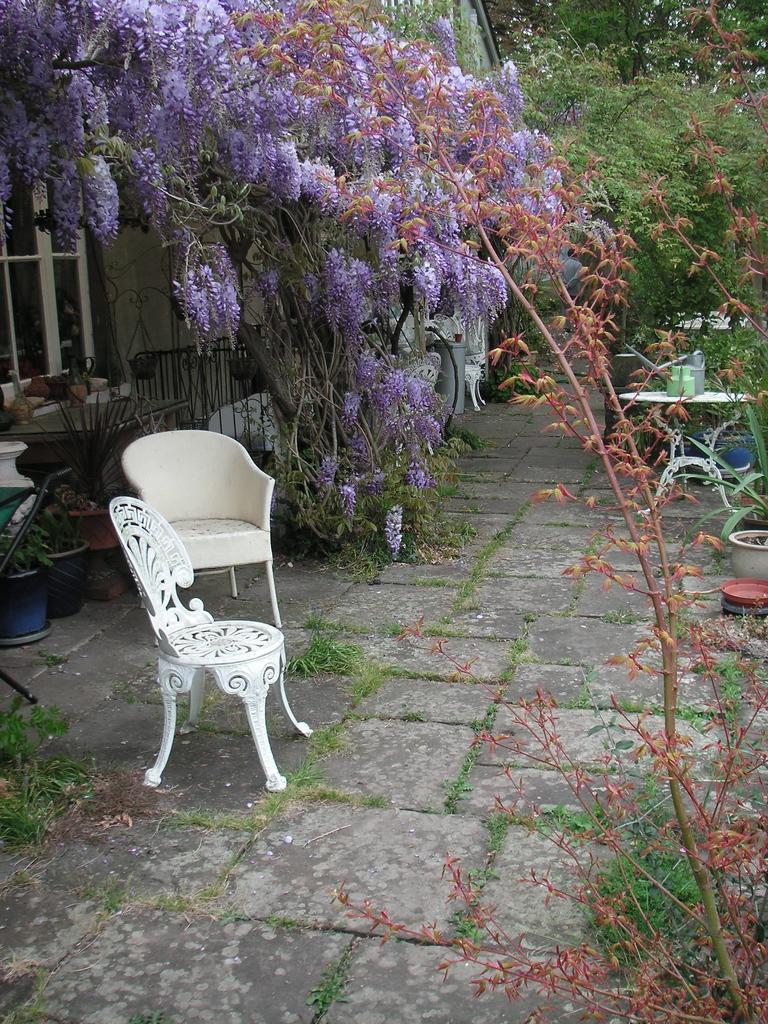Describe this image in one or two sentences. There are two white empty chairs. Here is a table with some objects on it. These are the trees with violet color flowers and heart are the flower pots. 